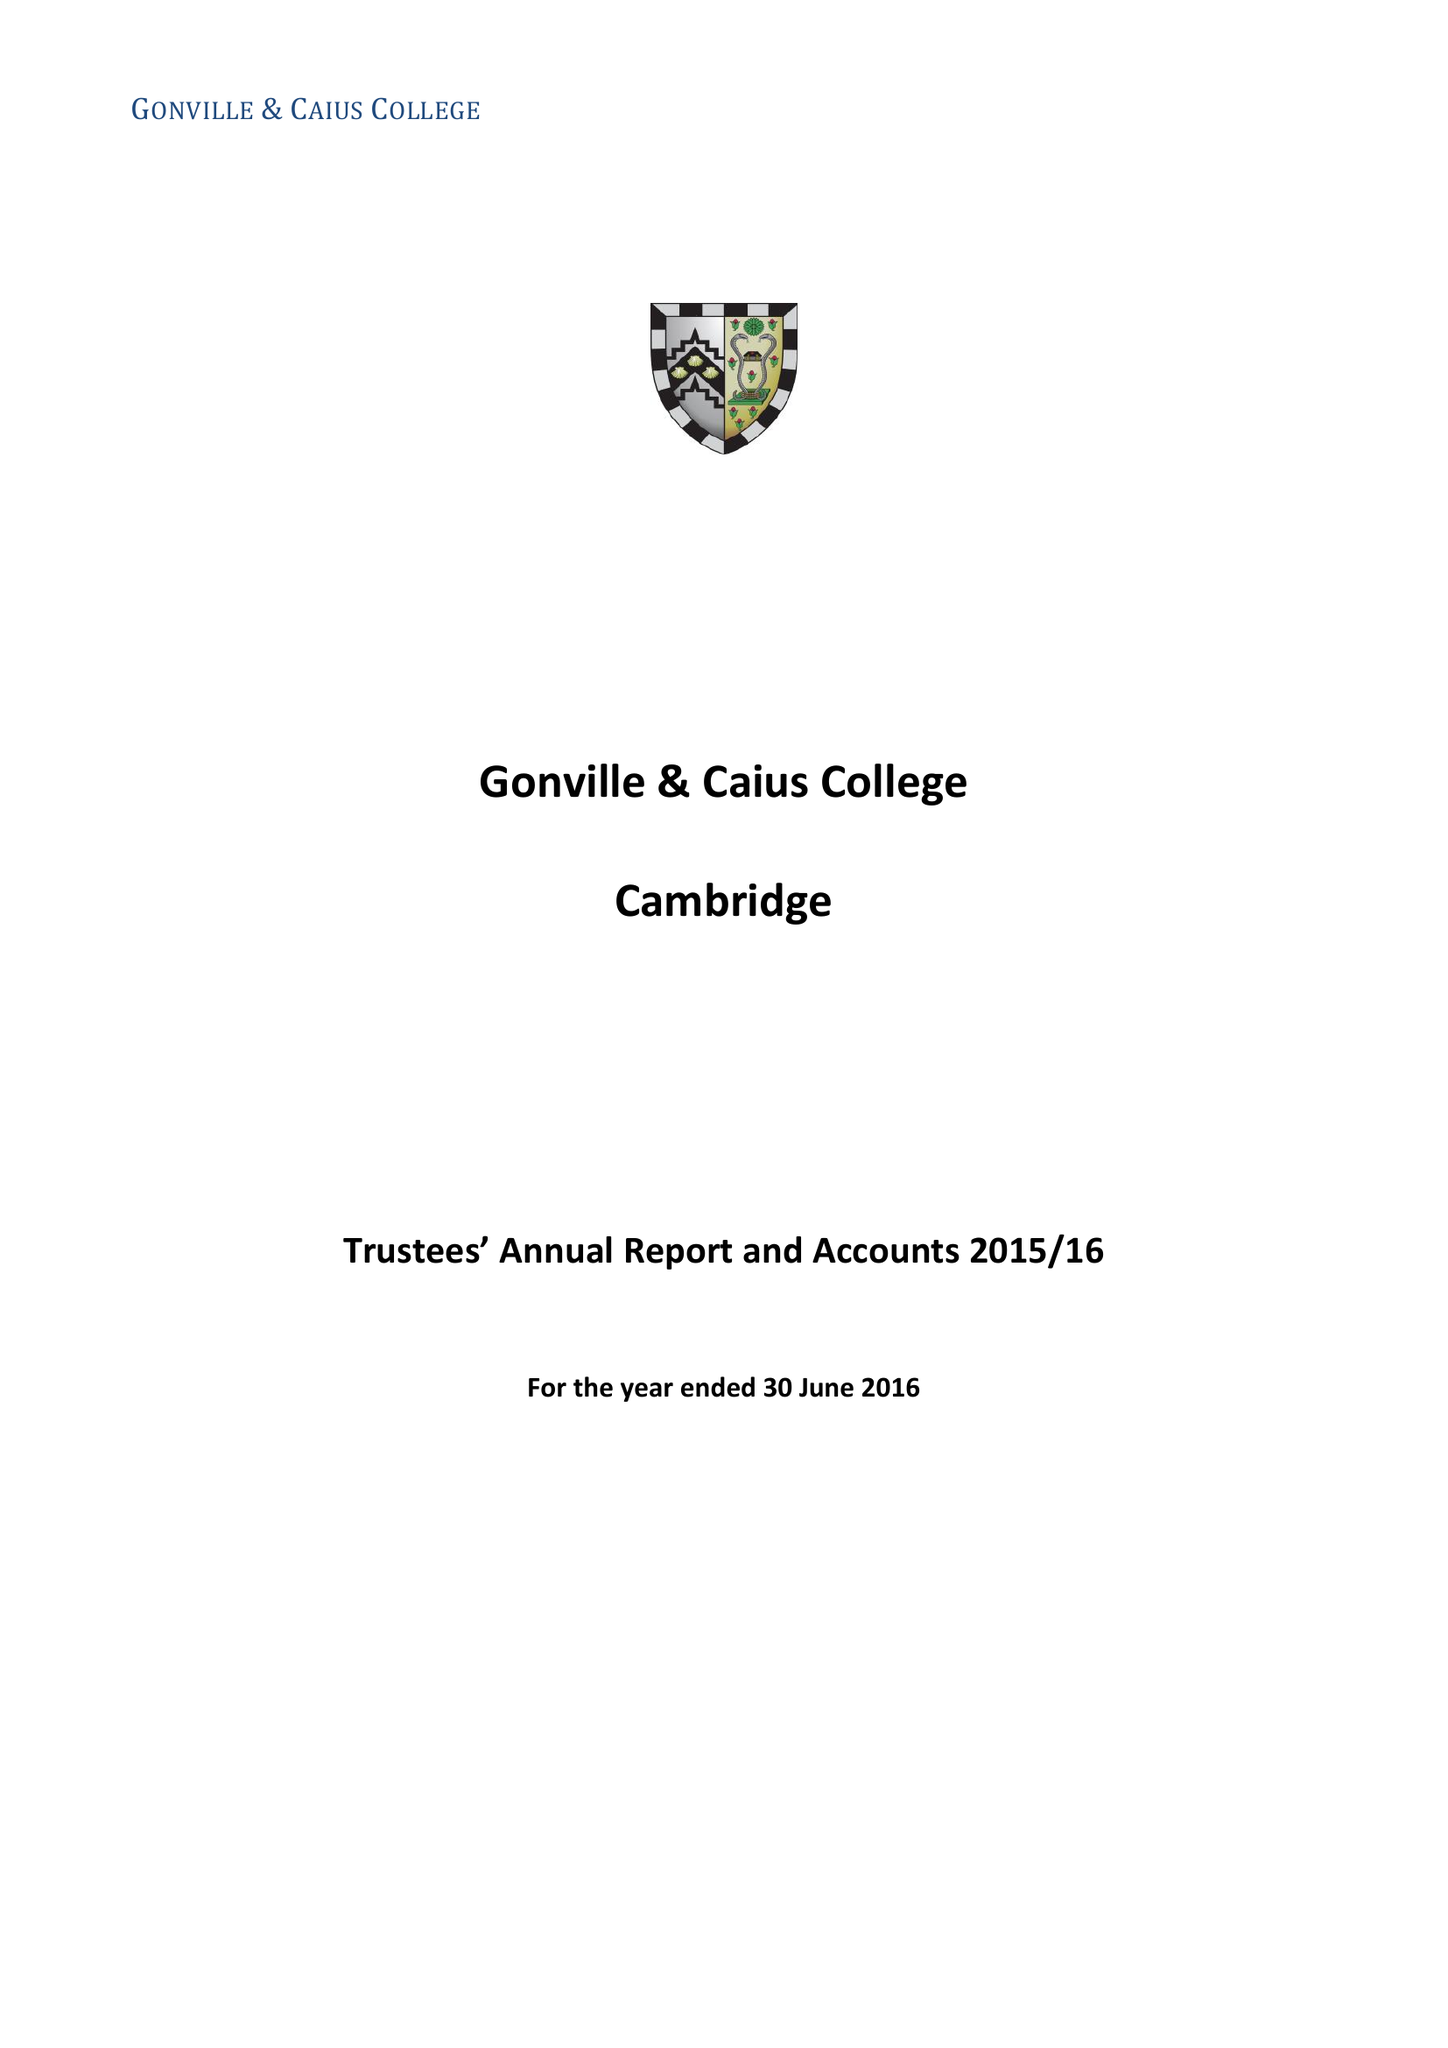What is the value for the address__postcode?
Answer the question using a single word or phrase. CB2 1TA 